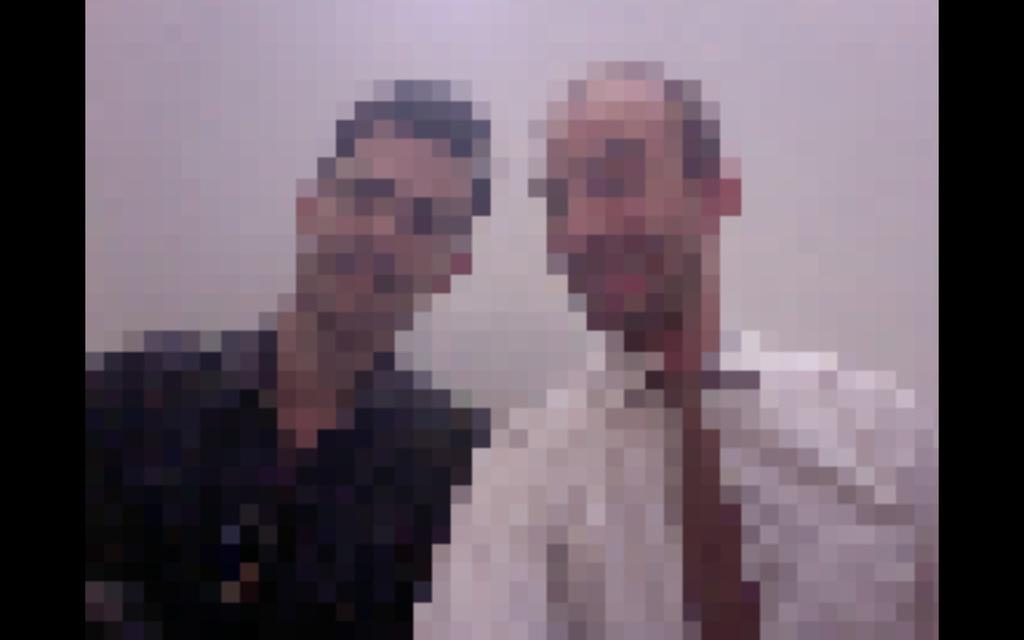What can be observed about the editing of the image? The image is edited. What type of images are present in the edited image? There are two blurred photos of persons in the image. What is the color of the background in the image? The background in the image is white. How many trees are visible in the image? There are no trees visible in the image, as the background is white and the focus is on the blurred photos of persons. 